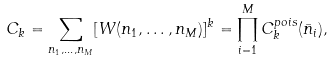Convert formula to latex. <formula><loc_0><loc_0><loc_500><loc_500>C _ { k } = \sum _ { n _ { 1 } , \dots , n _ { M } } [ W ( n _ { 1 } , \dots , n _ { M } ) ] ^ { k } = \prod _ { i = 1 } ^ { M } C _ { k } ^ { p o i s } ( \bar { n } _ { i } ) ,</formula> 